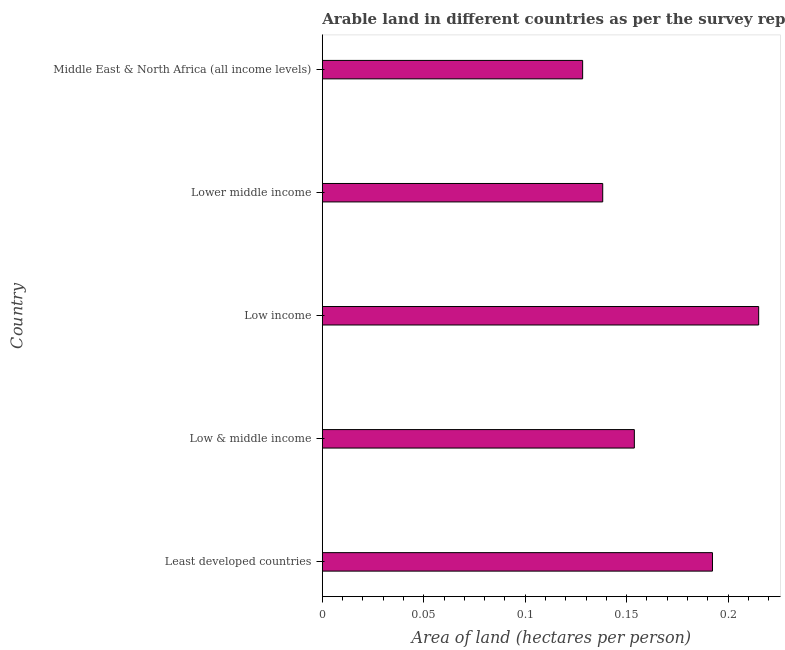Does the graph contain any zero values?
Give a very brief answer. No. Does the graph contain grids?
Make the answer very short. No. What is the title of the graph?
Give a very brief answer. Arable land in different countries as per the survey report of the year 2013. What is the label or title of the X-axis?
Provide a succinct answer. Area of land (hectares per person). What is the label or title of the Y-axis?
Your answer should be very brief. Country. What is the area of arable land in Middle East & North Africa (all income levels)?
Your response must be concise. 0.13. Across all countries, what is the maximum area of arable land?
Your answer should be compact. 0.22. Across all countries, what is the minimum area of arable land?
Keep it short and to the point. 0.13. In which country was the area of arable land maximum?
Your answer should be compact. Low income. In which country was the area of arable land minimum?
Ensure brevity in your answer.  Middle East & North Africa (all income levels). What is the sum of the area of arable land?
Ensure brevity in your answer.  0.83. What is the difference between the area of arable land in Least developed countries and Lower middle income?
Ensure brevity in your answer.  0.05. What is the average area of arable land per country?
Your answer should be very brief. 0.17. What is the median area of arable land?
Ensure brevity in your answer.  0.15. In how many countries, is the area of arable land greater than 0.07 hectares per person?
Your response must be concise. 5. What is the ratio of the area of arable land in Low income to that in Middle East & North Africa (all income levels)?
Give a very brief answer. 1.68. Is the area of arable land in Low & middle income less than that in Middle East & North Africa (all income levels)?
Give a very brief answer. No. What is the difference between the highest and the second highest area of arable land?
Offer a very short reply. 0.02. Is the sum of the area of arable land in Low & middle income and Middle East & North Africa (all income levels) greater than the maximum area of arable land across all countries?
Make the answer very short. Yes. What is the difference between the highest and the lowest area of arable land?
Keep it short and to the point. 0.09. How many countries are there in the graph?
Your response must be concise. 5. What is the difference between two consecutive major ticks on the X-axis?
Your answer should be compact. 0.05. Are the values on the major ticks of X-axis written in scientific E-notation?
Ensure brevity in your answer.  No. What is the Area of land (hectares per person) of Least developed countries?
Your response must be concise. 0.19. What is the Area of land (hectares per person) in Low & middle income?
Ensure brevity in your answer.  0.15. What is the Area of land (hectares per person) in Low income?
Make the answer very short. 0.22. What is the Area of land (hectares per person) of Lower middle income?
Your response must be concise. 0.14. What is the Area of land (hectares per person) of Middle East & North Africa (all income levels)?
Provide a short and direct response. 0.13. What is the difference between the Area of land (hectares per person) in Least developed countries and Low & middle income?
Offer a very short reply. 0.04. What is the difference between the Area of land (hectares per person) in Least developed countries and Low income?
Your response must be concise. -0.02. What is the difference between the Area of land (hectares per person) in Least developed countries and Lower middle income?
Give a very brief answer. 0.05. What is the difference between the Area of land (hectares per person) in Least developed countries and Middle East & North Africa (all income levels)?
Keep it short and to the point. 0.06. What is the difference between the Area of land (hectares per person) in Low & middle income and Low income?
Give a very brief answer. -0.06. What is the difference between the Area of land (hectares per person) in Low & middle income and Lower middle income?
Give a very brief answer. 0.02. What is the difference between the Area of land (hectares per person) in Low & middle income and Middle East & North Africa (all income levels)?
Offer a terse response. 0.03. What is the difference between the Area of land (hectares per person) in Low income and Lower middle income?
Your answer should be compact. 0.08. What is the difference between the Area of land (hectares per person) in Low income and Middle East & North Africa (all income levels)?
Your answer should be very brief. 0.09. What is the difference between the Area of land (hectares per person) in Lower middle income and Middle East & North Africa (all income levels)?
Ensure brevity in your answer.  0.01. What is the ratio of the Area of land (hectares per person) in Least developed countries to that in Low income?
Keep it short and to the point. 0.89. What is the ratio of the Area of land (hectares per person) in Least developed countries to that in Lower middle income?
Keep it short and to the point. 1.39. What is the ratio of the Area of land (hectares per person) in Least developed countries to that in Middle East & North Africa (all income levels)?
Provide a short and direct response. 1.5. What is the ratio of the Area of land (hectares per person) in Low & middle income to that in Low income?
Give a very brief answer. 0.71. What is the ratio of the Area of land (hectares per person) in Low & middle income to that in Lower middle income?
Provide a short and direct response. 1.11. What is the ratio of the Area of land (hectares per person) in Low & middle income to that in Middle East & North Africa (all income levels)?
Ensure brevity in your answer.  1.2. What is the ratio of the Area of land (hectares per person) in Low income to that in Lower middle income?
Offer a terse response. 1.56. What is the ratio of the Area of land (hectares per person) in Low income to that in Middle East & North Africa (all income levels)?
Give a very brief answer. 1.68. What is the ratio of the Area of land (hectares per person) in Lower middle income to that in Middle East & North Africa (all income levels)?
Provide a short and direct response. 1.08. 